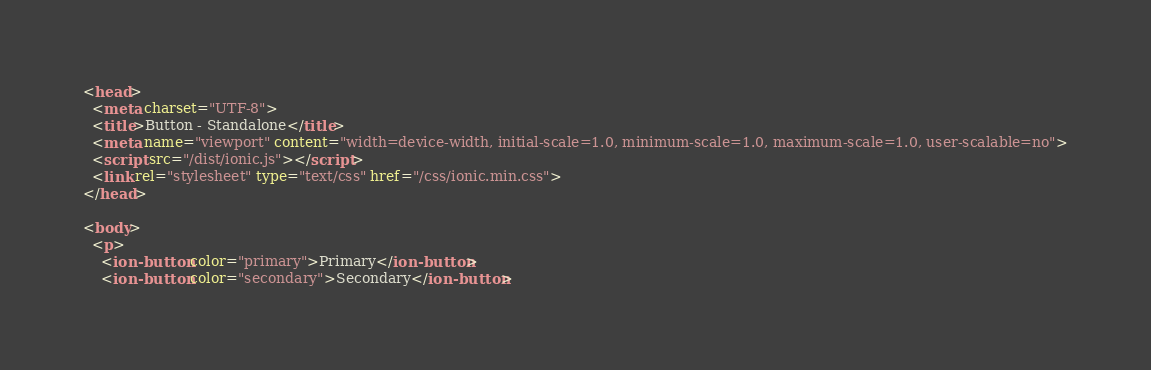<code> <loc_0><loc_0><loc_500><loc_500><_HTML_><head>
  <meta charset="UTF-8">
  <title>Button - Standalone</title>
  <meta name="viewport" content="width=device-width, initial-scale=1.0, minimum-scale=1.0, maximum-scale=1.0, user-scalable=no">
  <script src="/dist/ionic.js"></script>
  <link rel="stylesheet" type="text/css" href="/css/ionic.min.css">
</head>

<body>
  <p>
    <ion-button color="primary">Primary</ion-button>
    <ion-button color="secondary">Secondary</ion-button></code> 